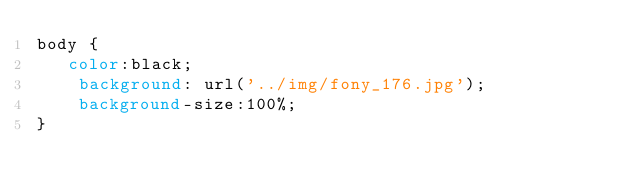<code> <loc_0><loc_0><loc_500><loc_500><_CSS_>body {
   color:black;
    background: url('../img/fony_176.jpg');
    background-size:100%;
}</code> 